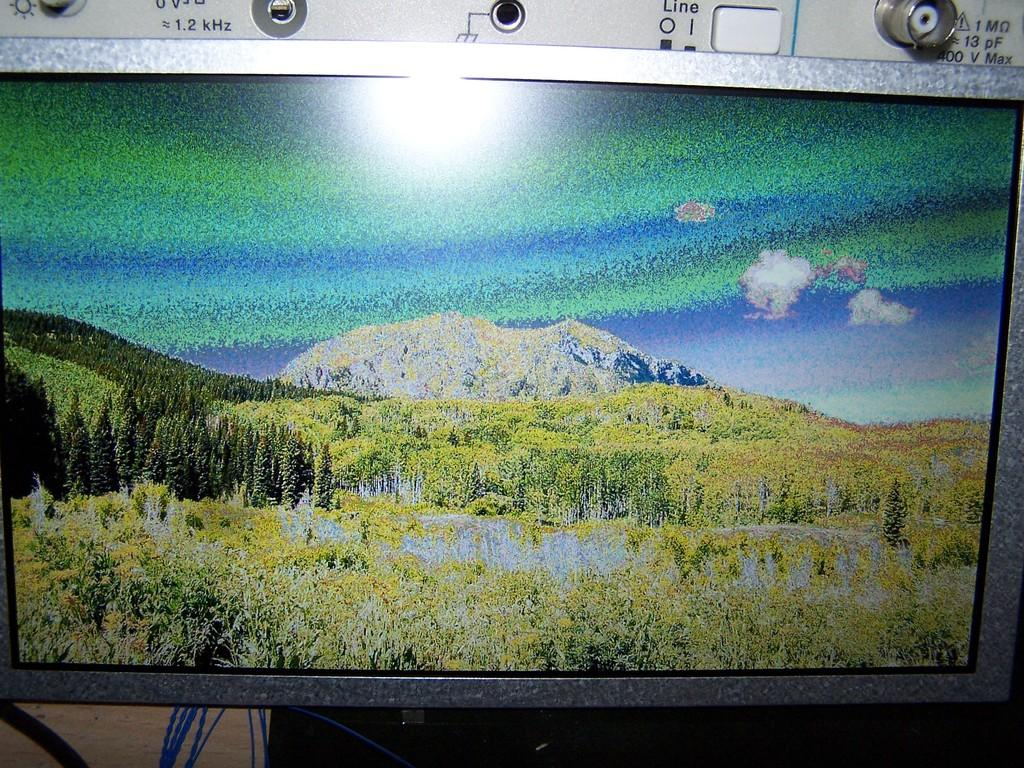<image>
Write a terse but informative summary of the picture. Above a screen, various inputs include one labeled "1.2 kHz". 